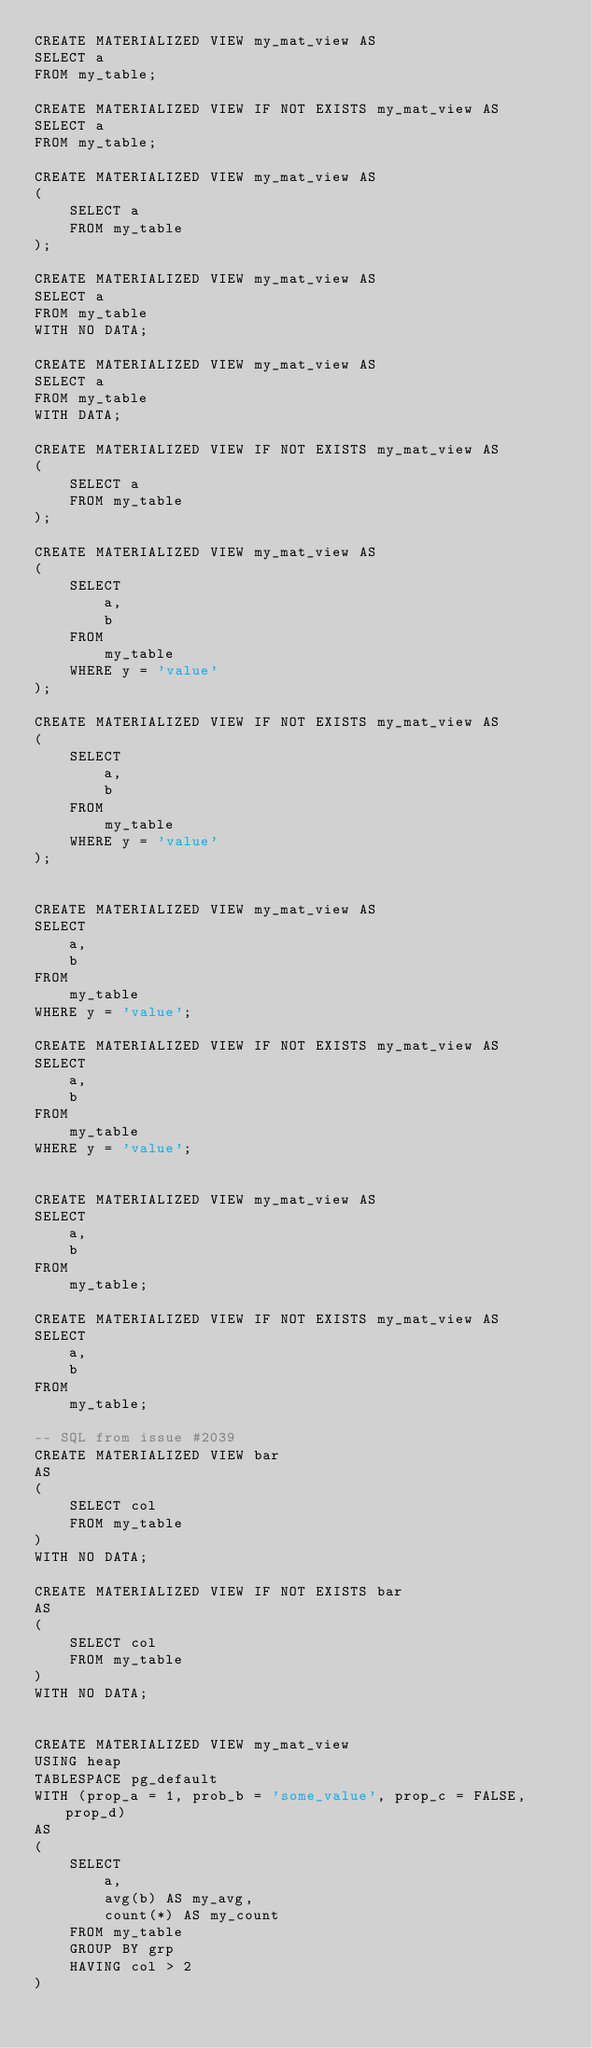Convert code to text. <code><loc_0><loc_0><loc_500><loc_500><_SQL_>CREATE MATERIALIZED VIEW my_mat_view AS
SELECT a
FROM my_table;

CREATE MATERIALIZED VIEW IF NOT EXISTS my_mat_view AS
SELECT a
FROM my_table;

CREATE MATERIALIZED VIEW my_mat_view AS
(
    SELECT a
    FROM my_table
);

CREATE MATERIALIZED VIEW my_mat_view AS
SELECT a
FROM my_table
WITH NO DATA;

CREATE MATERIALIZED VIEW my_mat_view AS
SELECT a
FROM my_table
WITH DATA;

CREATE MATERIALIZED VIEW IF NOT EXISTS my_mat_view AS
(
    SELECT a
    FROM my_table
);

CREATE MATERIALIZED VIEW my_mat_view AS
(
    SELECT
        a,
        b
    FROM
        my_table
    WHERE y = 'value'
);

CREATE MATERIALIZED VIEW IF NOT EXISTS my_mat_view AS
(
    SELECT
        a,
        b
    FROM
        my_table
    WHERE y = 'value'
);


CREATE MATERIALIZED VIEW my_mat_view AS
SELECT
    a,
    b
FROM
    my_table
WHERE y = 'value';

CREATE MATERIALIZED VIEW IF NOT EXISTS my_mat_view AS
SELECT
    a,
    b
FROM
    my_table
WHERE y = 'value';


CREATE MATERIALIZED VIEW my_mat_view AS
SELECT
    a,
    b
FROM
    my_table;

CREATE MATERIALIZED VIEW IF NOT EXISTS my_mat_view AS
SELECT
    a,
    b
FROM
    my_table;

-- SQL from issue #2039
CREATE MATERIALIZED VIEW bar
AS
(
    SELECT col
    FROM my_table
)
WITH NO DATA;

CREATE MATERIALIZED VIEW IF NOT EXISTS bar
AS
(
    SELECT col
    FROM my_table
)
WITH NO DATA;


CREATE MATERIALIZED VIEW my_mat_view
USING heap
TABLESPACE pg_default
WITH (prop_a = 1, prob_b = 'some_value', prop_c = FALSE, prop_d)
AS
(
    SELECT
        a,
        avg(b) AS my_avg,
        count(*) AS my_count
    FROM my_table
    GROUP BY grp
    HAVING col > 2
)</code> 